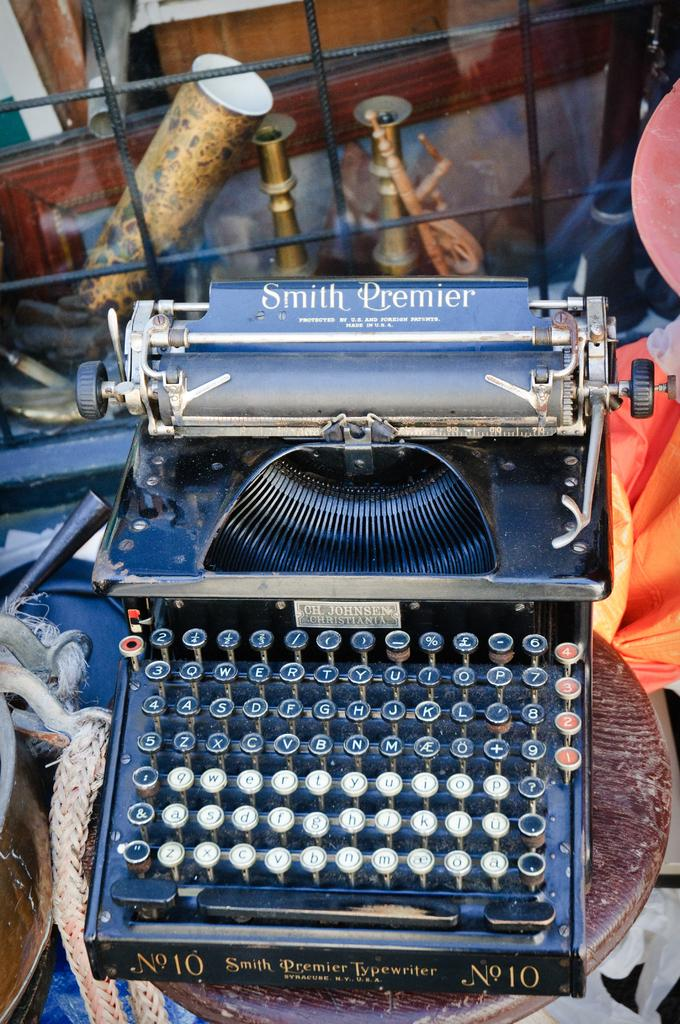<image>
Write a terse but informative summary of the picture. A blue colored Smith Premier typewriter is in an antique shop. 